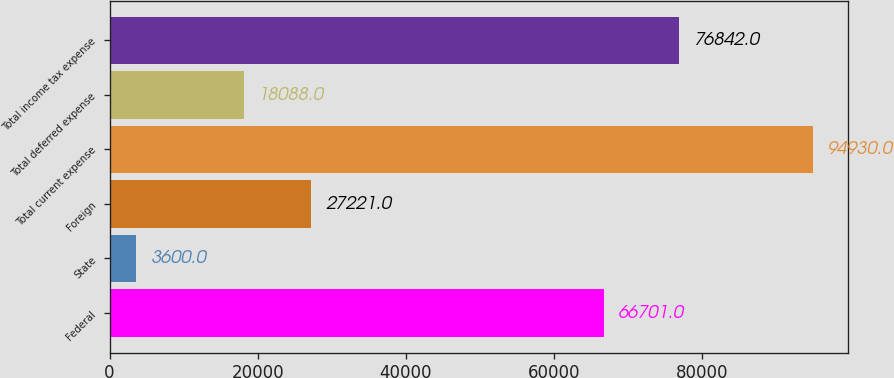<chart> <loc_0><loc_0><loc_500><loc_500><bar_chart><fcel>Federal<fcel>State<fcel>Foreign<fcel>Total current expense<fcel>Total deferred expense<fcel>Total income tax expense<nl><fcel>66701<fcel>3600<fcel>27221<fcel>94930<fcel>18088<fcel>76842<nl></chart> 